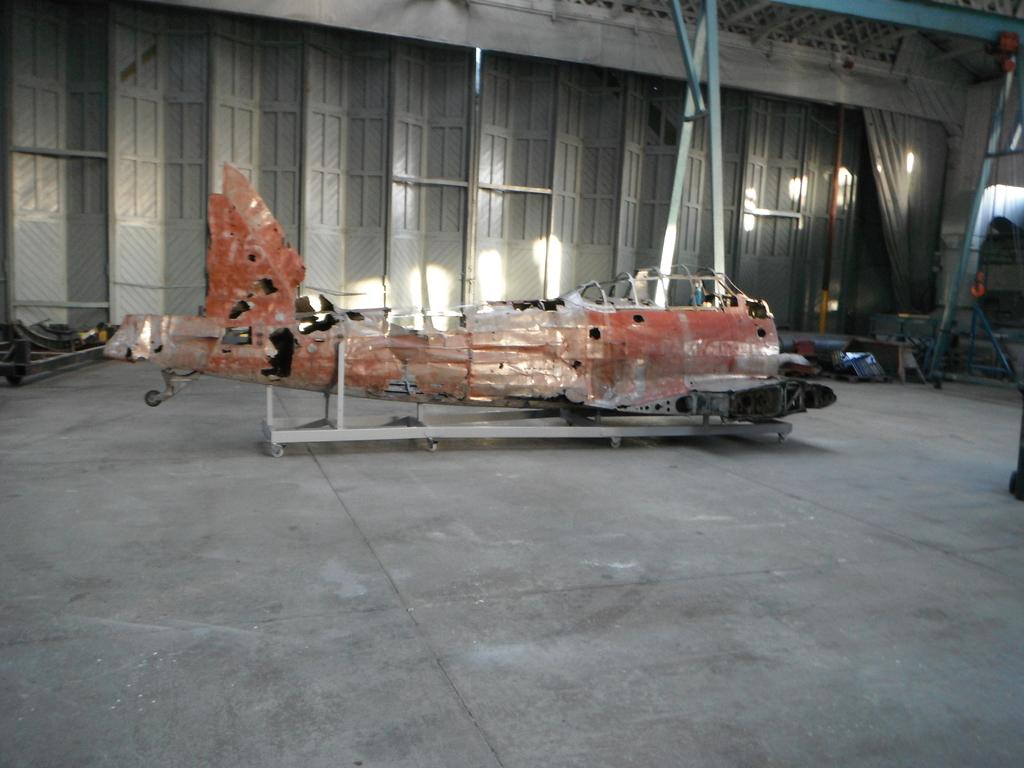What is the main subject of the image? The main subject of the image is a helicopter. Can you describe the condition of the helicopter? The helicopter is in a destroyed condition. What can be seen in the background of the image? There are doors in the background of the image. What is located on the right side of the image? There is a stand on the right side of the image. What type of objects are on the floor in the image? There are metal objects on the floor in the image. What type of vessel is floating in the image? There is no vessel present in the image; it features a destroyed helicopter and other objects. Can you tell me how many toothbrushes are visible in the image? There are no toothbrushes present in the image. 